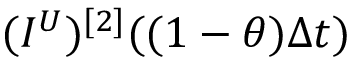<formula> <loc_0><loc_0><loc_500><loc_500>( I ^ { U } ) ^ { [ 2 ] } ( ( 1 - \theta ) \Delta t )</formula> 